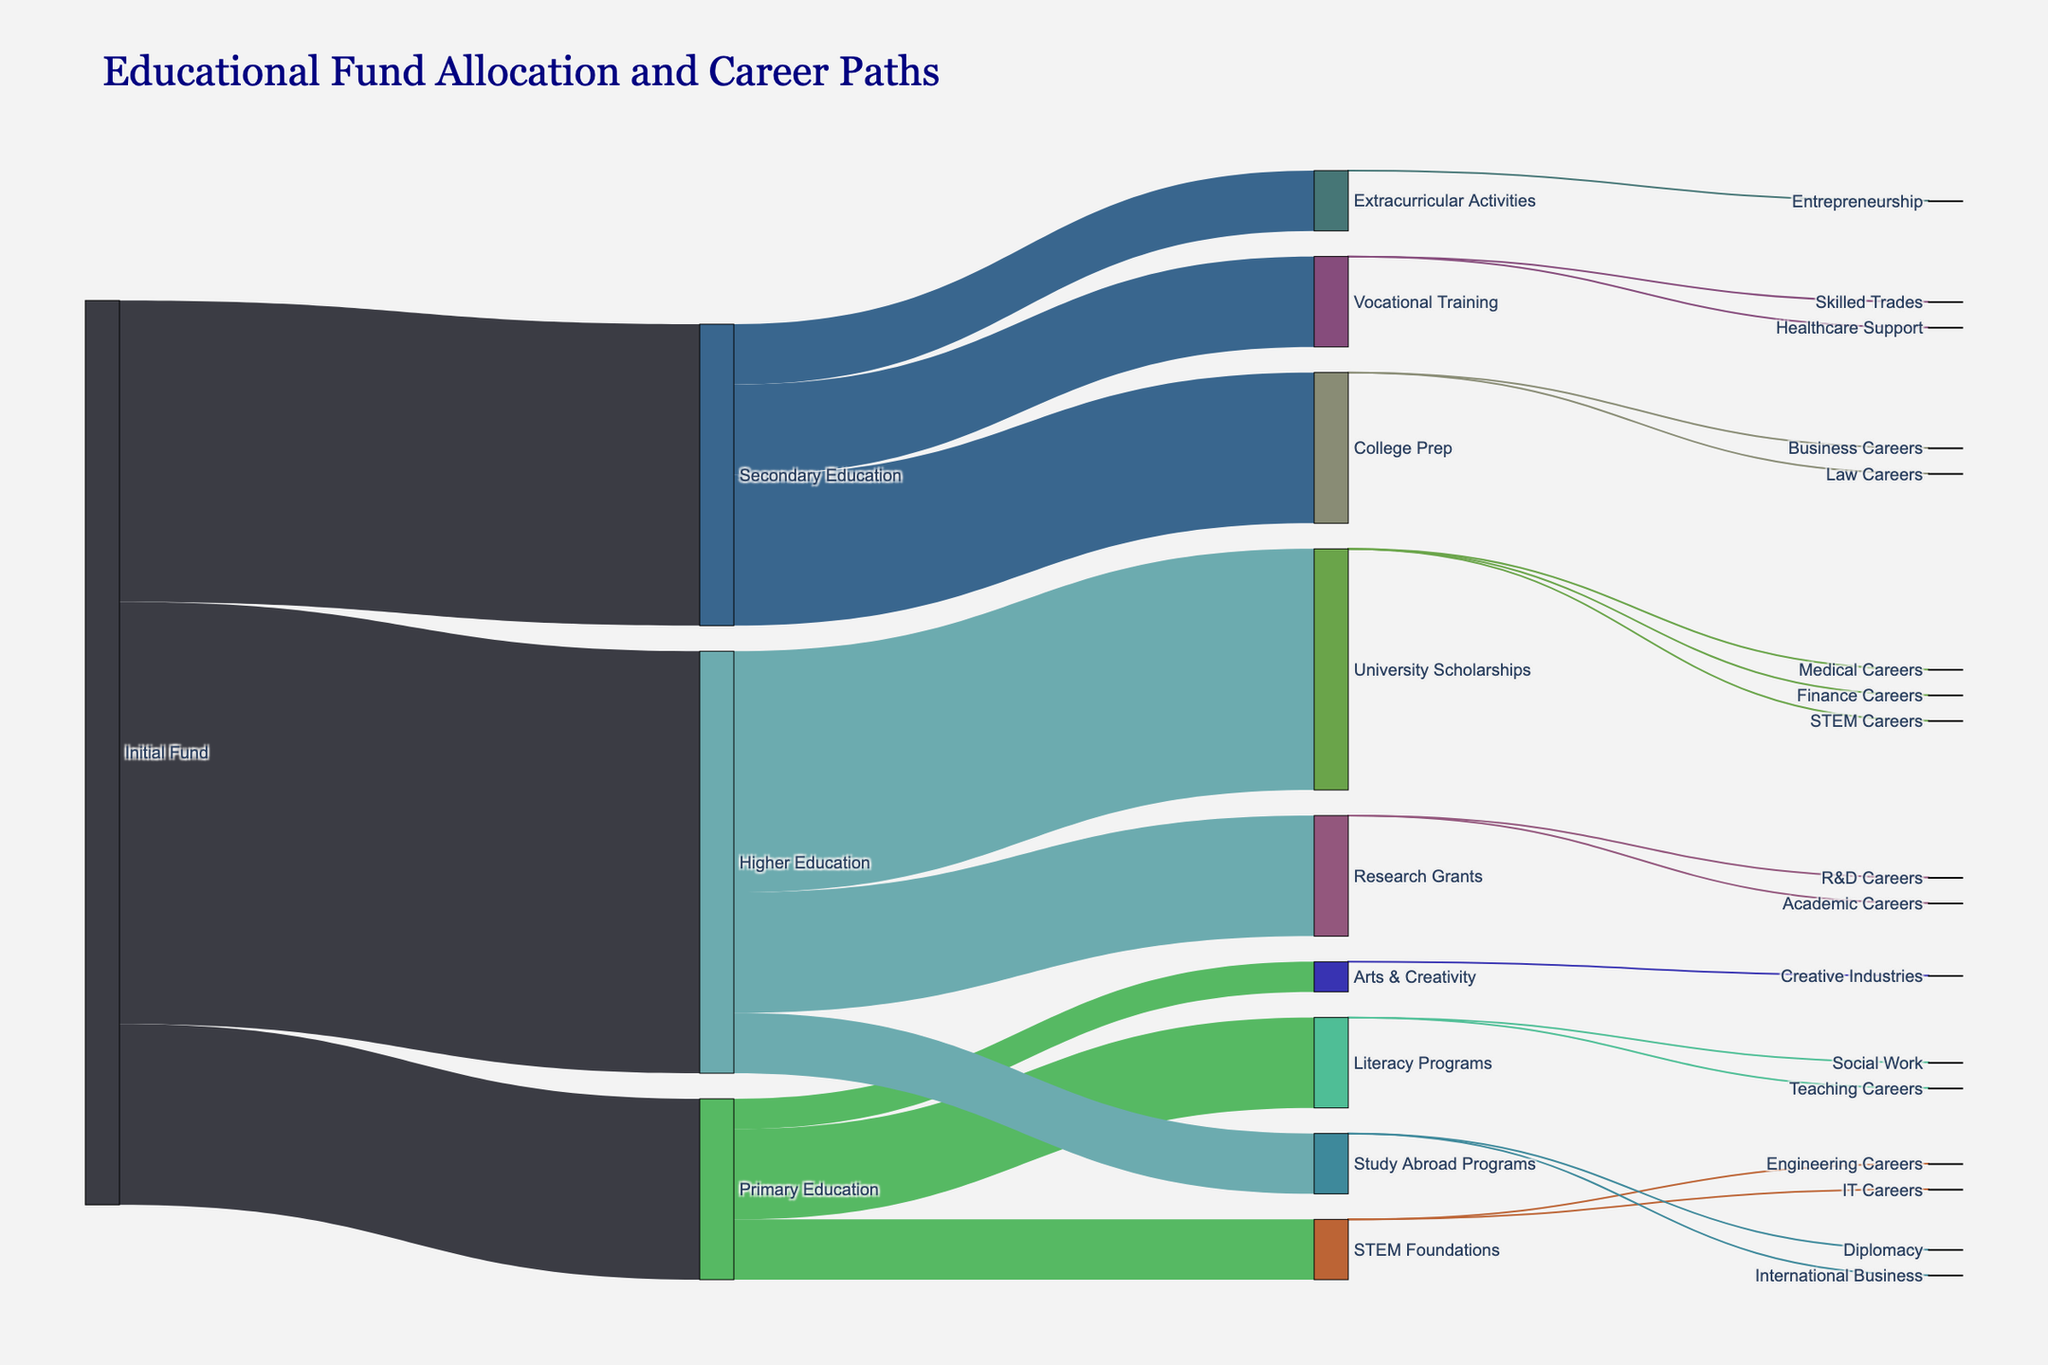what is the title of the figure? The title is typically located at the top of the figure. From the code, it is set as "Educational Fund Allocation and Career Paths", which would be displayed accordingly in the visual.
Answer: Educational Fund Allocation and Career Paths How much initial fund is allocated to primary education? In the Sankey diagram, the width of the connections between nodes represents the value. From the data, "Initial Fund" allocates 3,000,000 to "Primary Education".
Answer: 3,000,000 What is the total amount of funds allocated to secondary education? By checking the links from "Initial Fund" to "Secondary Education", the allocation is given as 5,000,000.
Answer: 5,000,000 Which educational category received the highest initial fund allocation? Comparing the initial fund allocations to primary, secondary, and higher education, "Higher Education" received the highest with 7,000,000.
Answer: Higher Education How many beneficiaries pursued IT careers from the STEM foundations in primary education? Checking the links from "STEM Foundations" to career paths, 350 beneficiaries pursued IT careers.
Answer: 350 What is the combined total of funds allocated to literacy programs and STEM foundations from primary education? The funds allocated to "Literacy Programs" and "STEM Foundations" are 1,500,000 and 1,000,000 respectively. Summing them up gives 2,500,000.
Answer: 2,500,000 How does the funding for university scholarships compare to research grants in higher education? The width of the connections indicates values. For higher education, "University Scholarships" received 4,000,000 whereas "Research Grants" received 2,000,000. University scholarships received double the funding of research grants.
Answer: University Scholarships received double the funding of Research Grants What is the total number of beneficiaries pursuing medical careers through university scholarships? From the link between “University Scholarships” and “Medical Careers”, the number of beneficiaries is 600.
Answer: 600 How many educational initiatives are funded by the initial fund? The initial fund is distributed to 3 categories: Primary Education, Secondary Education, and Higher Education. Each category further leads to various programs.
Answer: 3 primary categories Which career path received the least number of beneficiaries from study abroad programs? The links from "Study Abroad Programs" to careers show that "Diplomacy" received 100 beneficiaries, less than "International Business" which had 150.
Answer: Diplomacy 